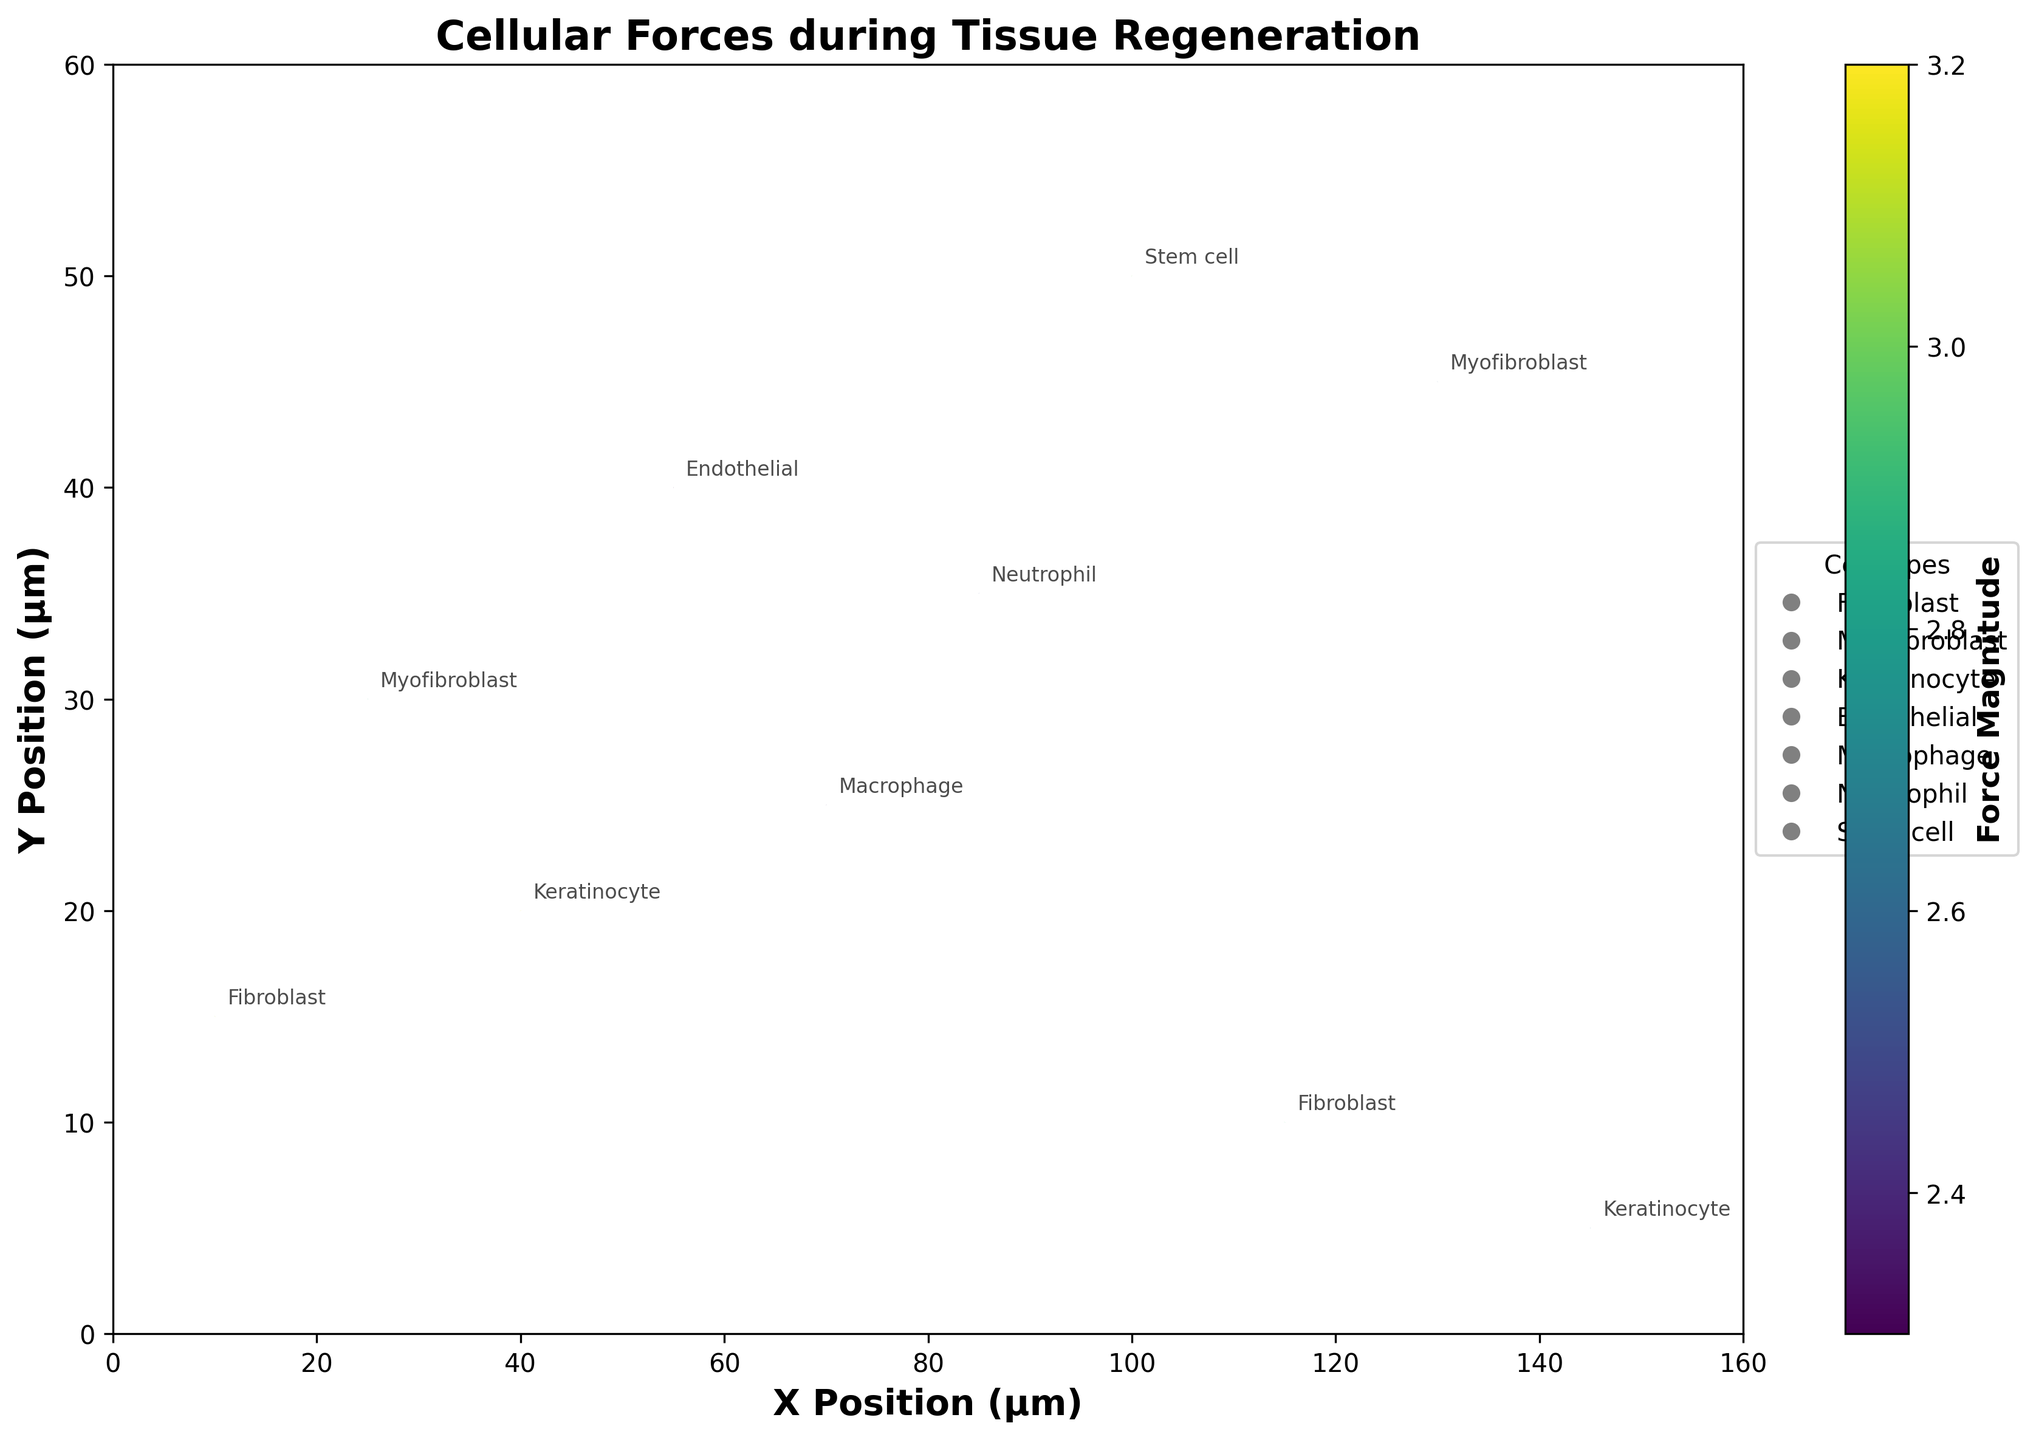What's the title of the figure? The title is located at the top of the figure and is typically bold and larger than other text. In this case, it’s clearly displayed as "Cellular Forces during Tissue Regeneration".
Answer: Cellular Forces during Tissue Regeneration How many cell types are represented in the plot? The cell types are annotated next to each quiver arrow. By counting the unique cell type labels, we can determine there are six different cell types shown: Fibroblast, Myofibroblast, Keratinocyte, Endothelial, Macrophage, Neutrophil, and Stem cell.
Answer: 6 Which cell type is associated with the highest force magnitude? By observing the color gradient, which represents force magnitude, we identify the highest magnitude by the most intense color. The cell types associated with the highest magnitudes (around 3.1-3.2) are Fibroblast and Keratinocyte. However, specifically, the highest magnitude (3.2) is associated with the Keratinocyte at position (40, 20).
Answer: Keratinocyte What is the direction of the force vector for the Stem cell? The quiver plot shows arrows for force direction. The arrow for the Stem cell at position (100, 50) points roughly upwards and slightly to the right, indicating a direction vector of approximately (0.7, 2.9).
Answer: Upwards and slightly to the right What are the x and y positions for the Fibroblast with the lowest force magnitude? By examining the positions of Fibroblasts and comparing their magnitudes: Fibroblast at (10, 15) and Fibroblast at (115, 10), the one at (10, 15) has a lower magnitude of 3.1.
Answer: (10, 15) Which cell type has a force vector pointing downwards? The direction of the vector can be inferred by looking at the vector components (u, v); a negative v component indicates a downwards direction. Endothelial and Neutrophil both have vectors pointing downwards, as does Keratinocyte (at 145,5).
Answer: Keratinocyte, Endothelial, Neutrophil What's the force vector for the Myofibroblast at position (25, 30)? The quiver arrow pointing from (25, 30) represents the Myofibroblast’s force vector, which is (-1.2, 2.7). This is represented by the direction and length of the arrow.
Answer: (-1.2, 2.7) Where is the Macrophage located, and what is its force magnitude? The Macrophage can be identified by its label at position (70, 25). Referring to the color and magnitude field, its associated force magnitude is 2.4.
Answer: (70, 25), 2.4 Compare the magnitudes of forces between the Fibroblasts and Myofibroblasts. Which cell type experiences higher average force? For Fibroblasts at (10, 15) and (115, 10), the magnitudes are 3.1 and 2.9, respectively. For Myofibroblasts at (25, 30) and (130, 45), the magnitudes are 2.9 and 2.6. The average magnitude for Fibroblasts is (3.1 + 2.9) / 2 = 3.0. The average magnitude for Myofibroblasts is (2.9 + 2.6) / 2 = 2.75.
Answer: Fibroblasts Which cell type has the longest arrow in the plot? The length of the arrow represents the magnitude of the force. The longest arrow corresponds to the highest magnitude, which is 3.2 belonging to the Keratinocyte at (40, 20).
Answer: Keratinocyte 